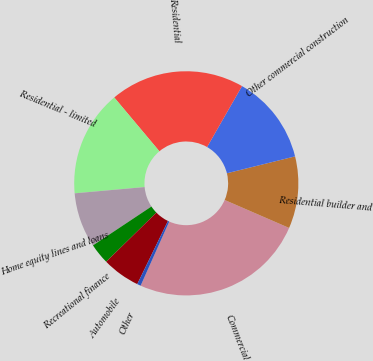Convert chart. <chart><loc_0><loc_0><loc_500><loc_500><pie_chart><fcel>Commercial<fcel>Residential builder and<fcel>Other commercial construction<fcel>Residential<fcel>Residential - limited<fcel>Home equity lines and loans<fcel>Recreational finance<fcel>Automobile<fcel>Other<nl><fcel>25.16%<fcel>10.38%<fcel>12.85%<fcel>19.39%<fcel>15.31%<fcel>7.92%<fcel>2.99%<fcel>5.46%<fcel>0.53%<nl></chart> 